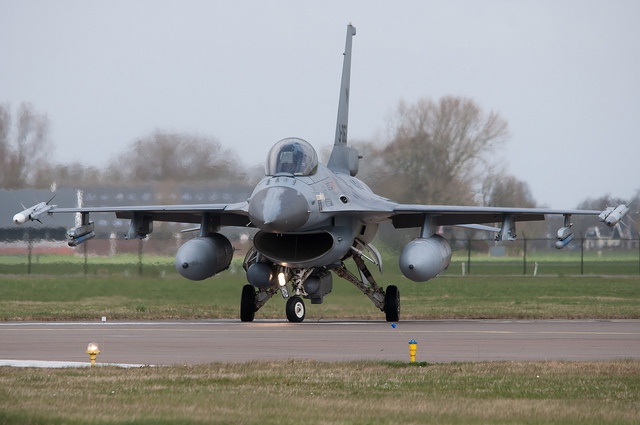Describe the objects in this image and their specific colors. I can see a airplane in lightgray, black, gray, and darkgray tones in this image. 